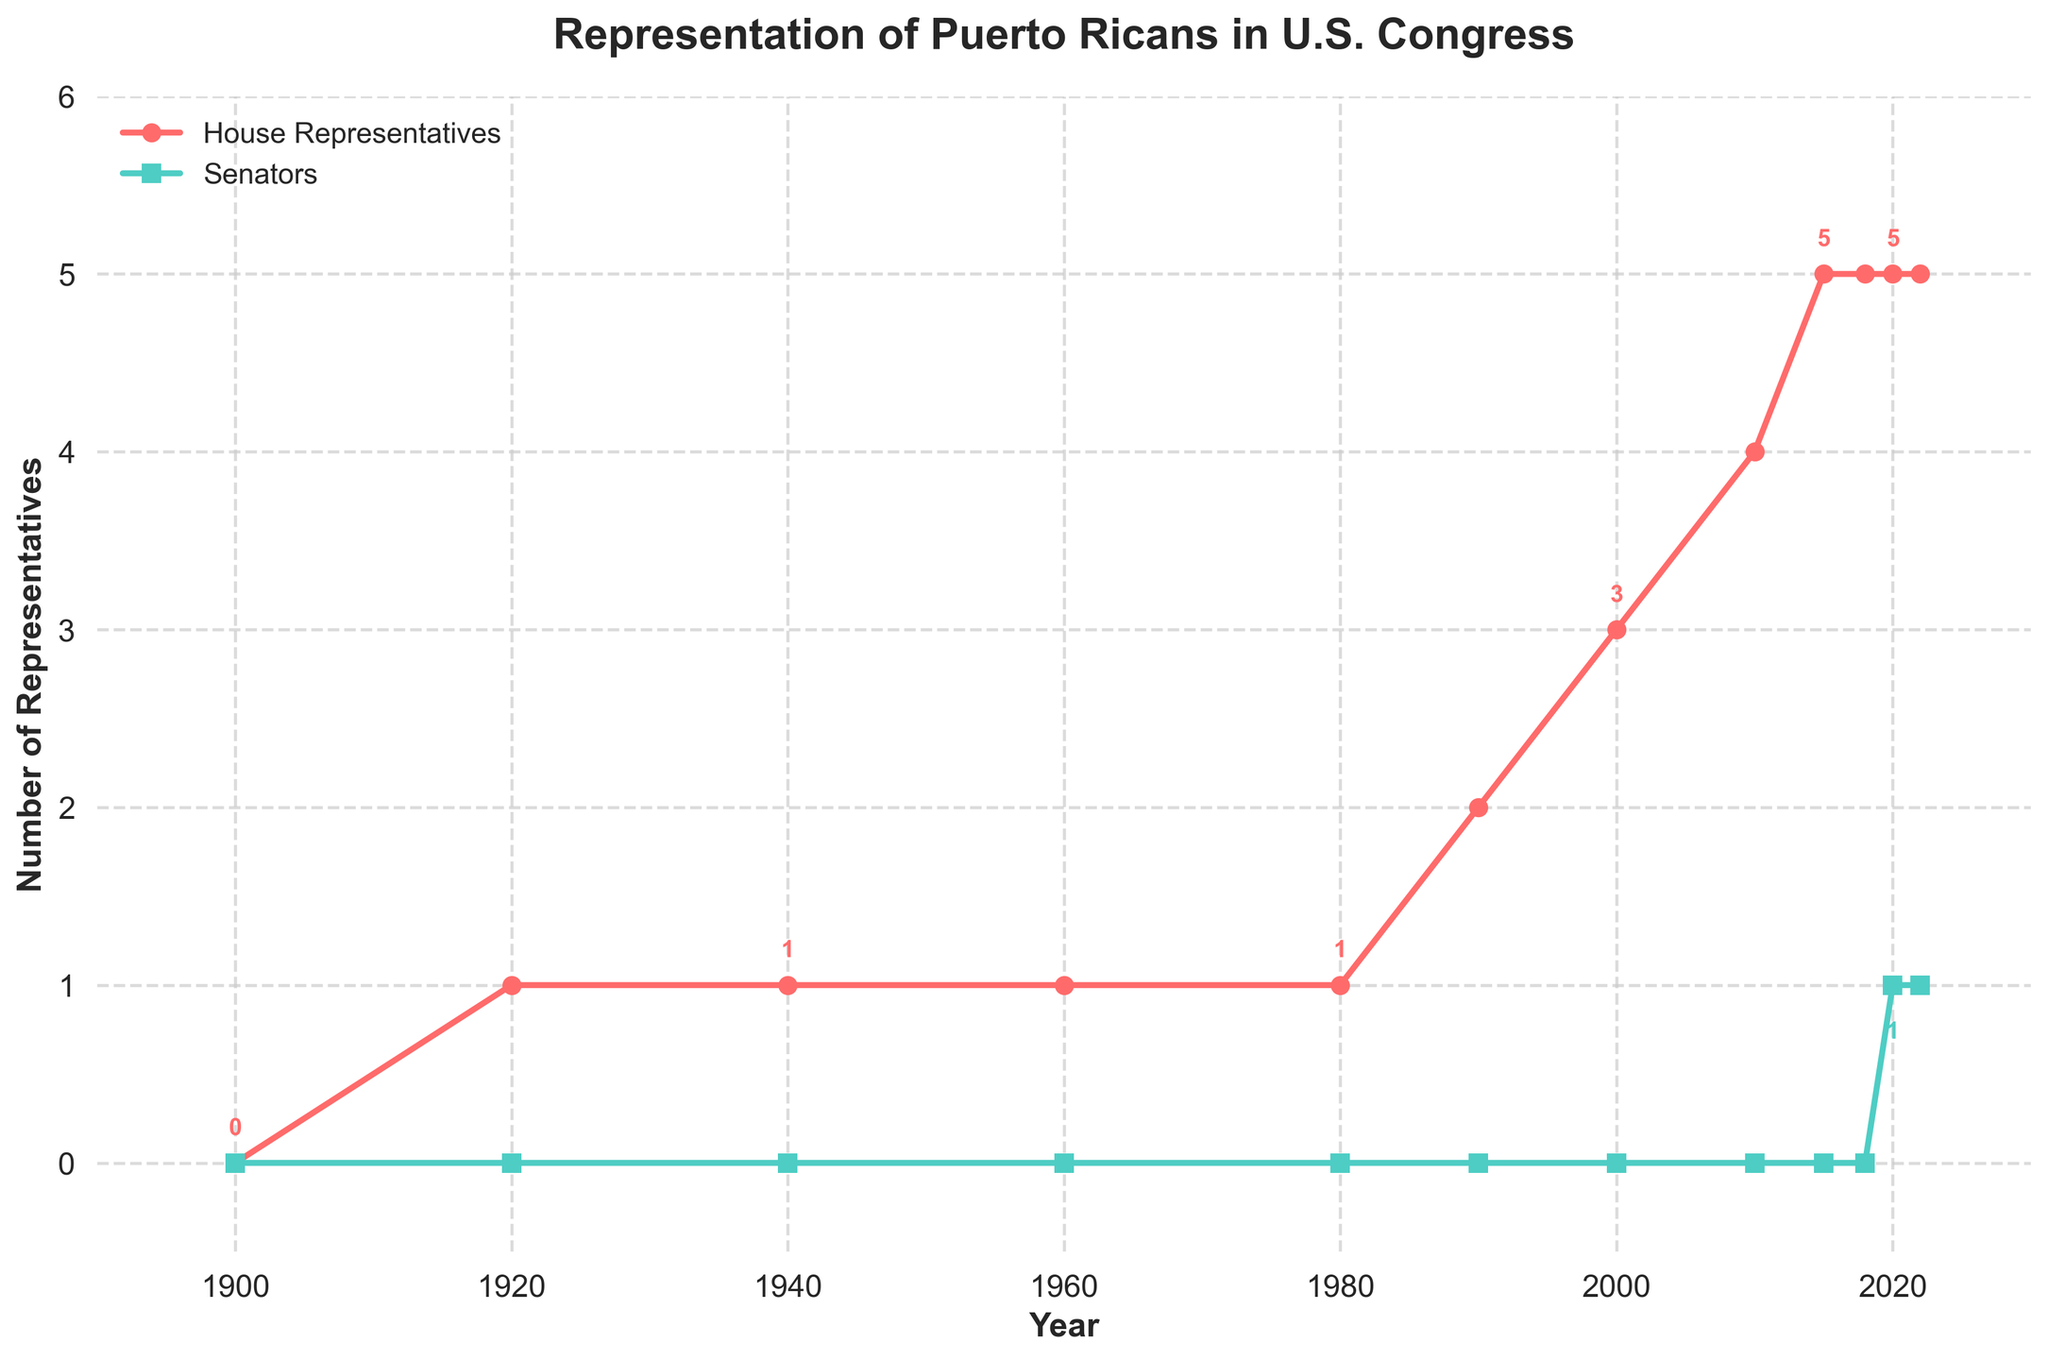What is the trend in the number of Puerto Rican House Representatives from 1900 to 2022? The line chart shows an initial period with no representatives, followed by a steady increase starting around 1920. There is a noticeable increase in the number of representatives after 1980, indicating growth in representation over time.
Answer: Increasing trend When did Puerto Ricans first have representatives in the House of Representatives? The earliest data point showing a Puerto Rican representative in the House is in the year 1920, as indicated by the line chart.
Answer: 1920 How many Puerto Rican senators were there before 2020? By examining the line representing senators, it can be seen that there are no data points above zero before 2020. The first senator appears in the year 2020.
Answer: 0 What is the difference in the number of House Representatives and Senators in the year 2020? In 2020, the chart shows 5 House Representatives and 1 Senator. The difference is calculated as 5 - 1.
Answer: 4 During which period did the greatest increase in Puerto Rican House Representatives occur? Looking at the steepness of the slope, the greatest increase occurred between 1990 and 2010, where the number of representatives rose from 2 to 4.
Answer: 1990-2010 Which year had the highest combined total of House Representatives and Senators? The combined totals for each year need to be evaluated. The year 2020 has the highest with 5 Representatives and 1 Senator, making a total of 6.
Answer: 2020 How many House Representatives were there in 1980 compared to 2022? The chart shows that there was 1 House Representative in 1980 and 5 House Representatives in 2022.
Answer: 1 in 1980, 5 in 2022 Is there any year where the number of Senators is greater than the number of House Representatives? By examining the plotted lines, there is no year where the number of Senators exceeds the number of House Representatives.
Answer: No What visual attribute differentiates the lines representing House Representatives from Senators? The visual attributes of the lines are their color and marker shape. The House Representatives line is red with circular markers, and the Senators line is green with square markers.
Answer: Color and marker shape 